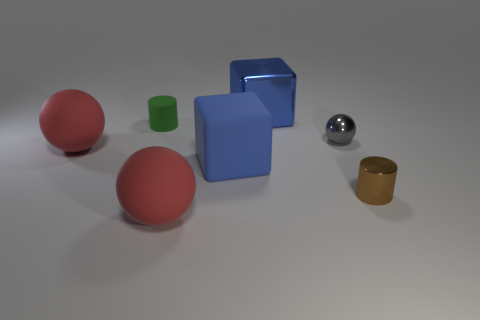There is another rubber thing that is the same shape as the brown thing; what size is it?
Your response must be concise. Small. How many big objects are either blue rubber objects or purple balls?
Ensure brevity in your answer.  1. Is the number of red balls that are behind the brown shiny cylinder greater than the number of brown cylinders behind the metallic cube?
Your answer should be compact. Yes. How many other things are there of the same size as the gray thing?
Provide a short and direct response. 2. Is the material of the object in front of the brown object the same as the tiny brown cylinder?
Your answer should be very brief. No. What number of other things are the same color as the metal block?
Your answer should be compact. 1. What number of other objects are there of the same shape as the big metal thing?
Give a very brief answer. 1. Does the big blue object that is in front of the small shiny sphere have the same shape as the blue thing that is behind the green thing?
Provide a short and direct response. Yes. Is the number of blue matte blocks behind the small sphere the same as the number of gray things on the left side of the big blue rubber cube?
Keep it short and to the point. Yes. What shape is the big rubber thing that is left of the large red sphere on the right side of the red matte sphere behind the brown object?
Your answer should be very brief. Sphere. 